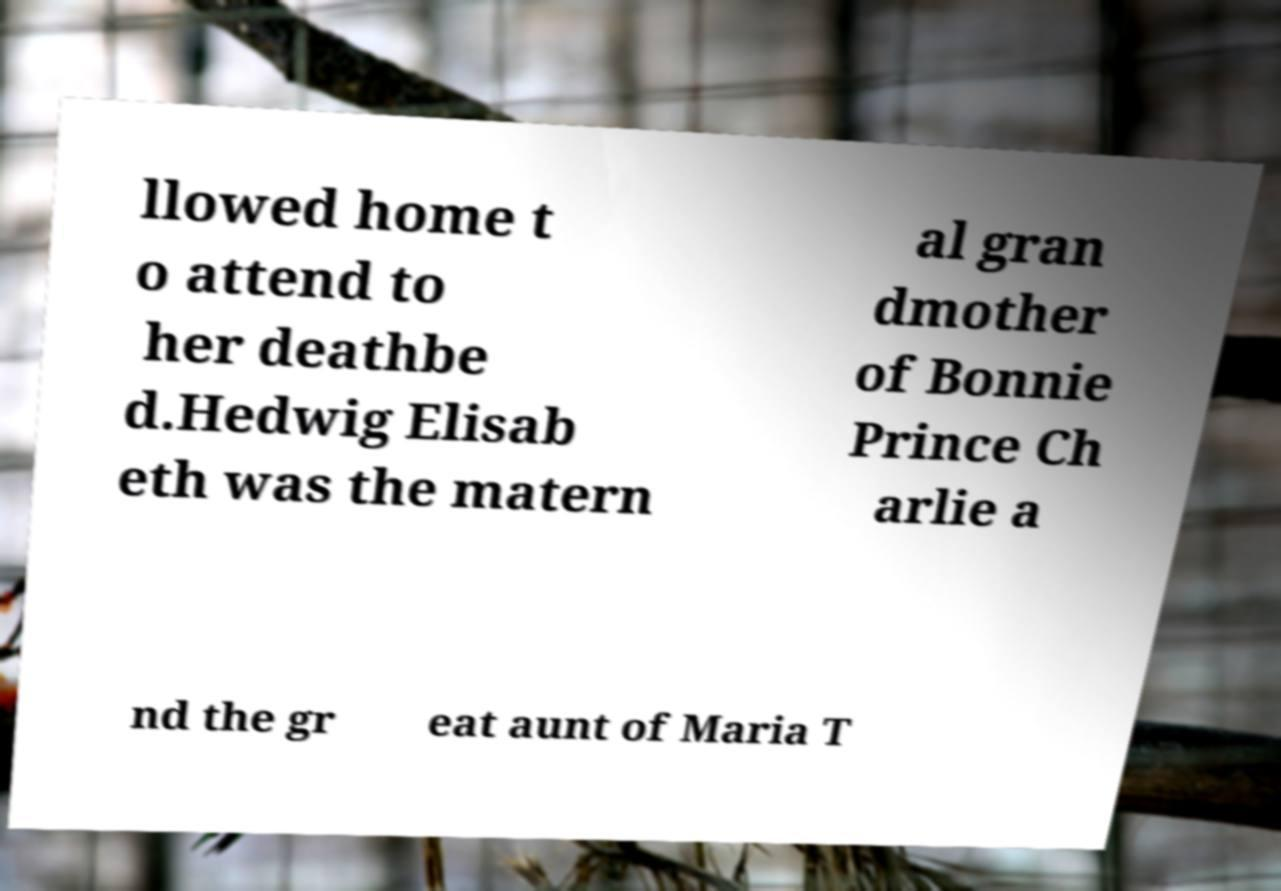Could you extract and type out the text from this image? llowed home t o attend to her deathbe d.Hedwig Elisab eth was the matern al gran dmother of Bonnie Prince Ch arlie a nd the gr eat aunt of Maria T 